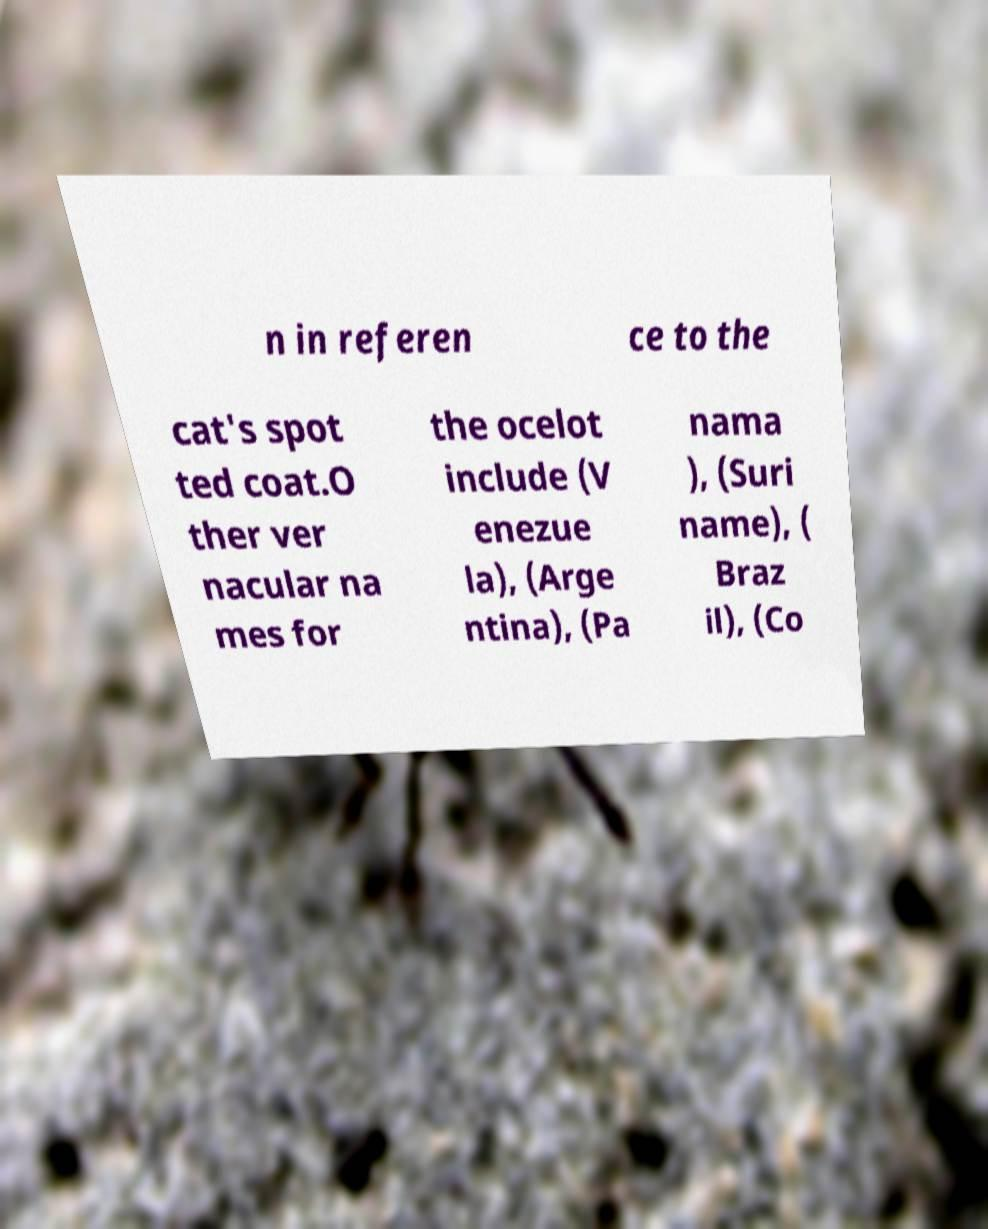I need the written content from this picture converted into text. Can you do that? n in referen ce to the cat's spot ted coat.O ther ver nacular na mes for the ocelot include (V enezue la), (Arge ntina), (Pa nama ), (Suri name), ( Braz il), (Co 